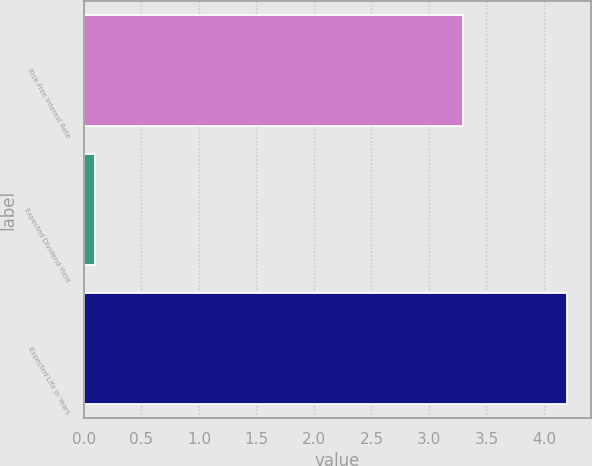Convert chart to OTSL. <chart><loc_0><loc_0><loc_500><loc_500><bar_chart><fcel>Risk-Free Interest Rate<fcel>Expected Dividend Yield<fcel>Expected Life in Years<nl><fcel>3.3<fcel>0.1<fcel>4.2<nl></chart> 